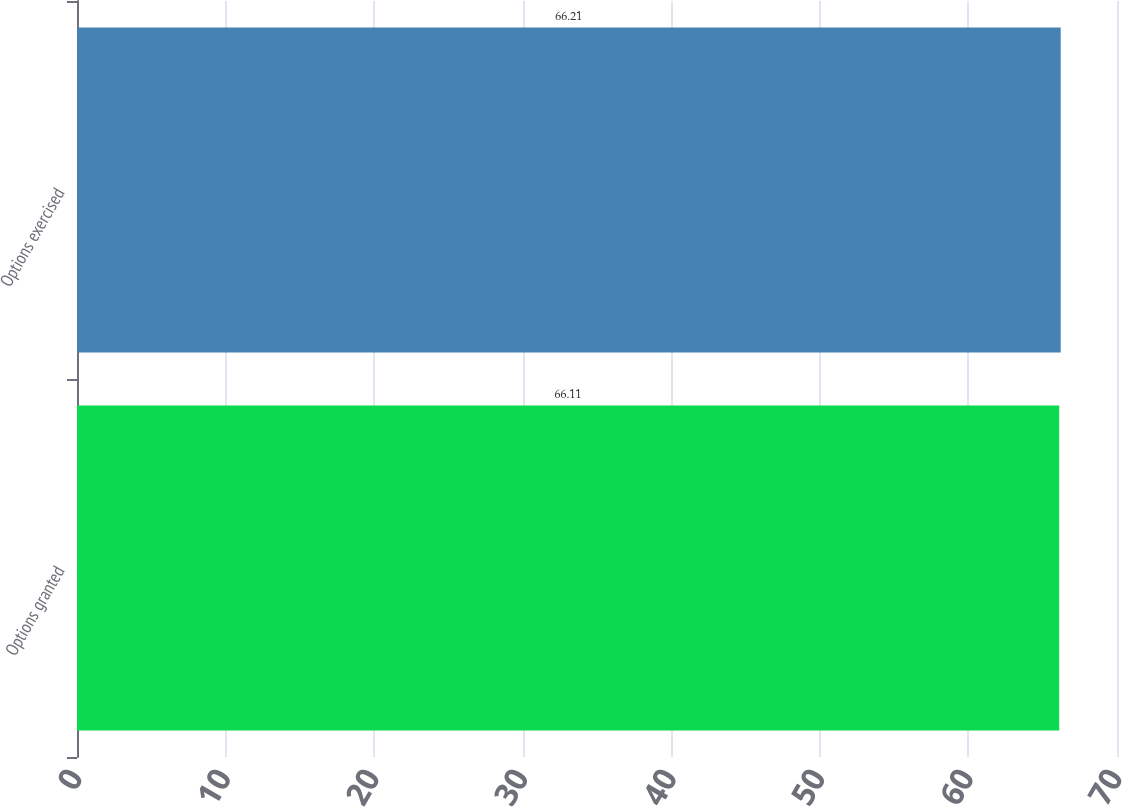<chart> <loc_0><loc_0><loc_500><loc_500><bar_chart><fcel>Options granted<fcel>Options exercised<nl><fcel>66.11<fcel>66.21<nl></chart> 